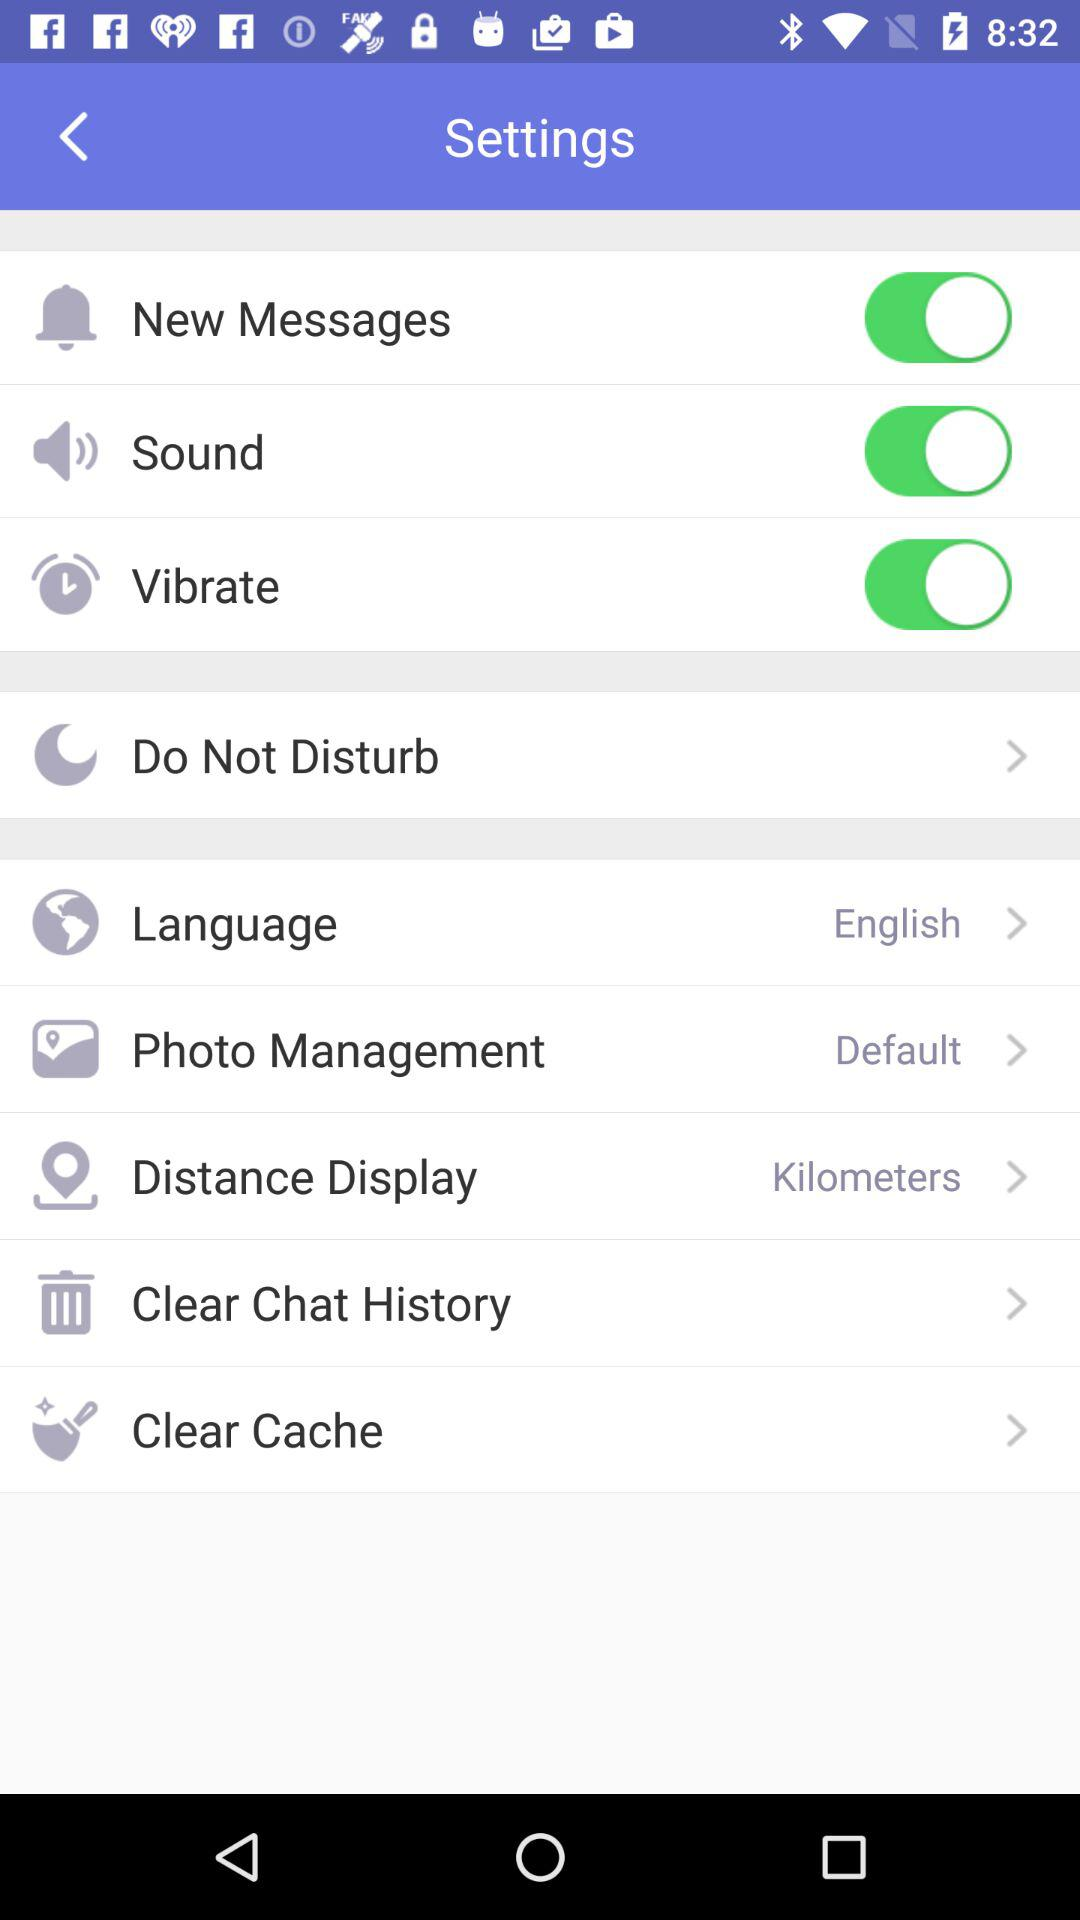What are the names of the enabled options? The names are "New Messages", "Sound" and "Vibrate". 